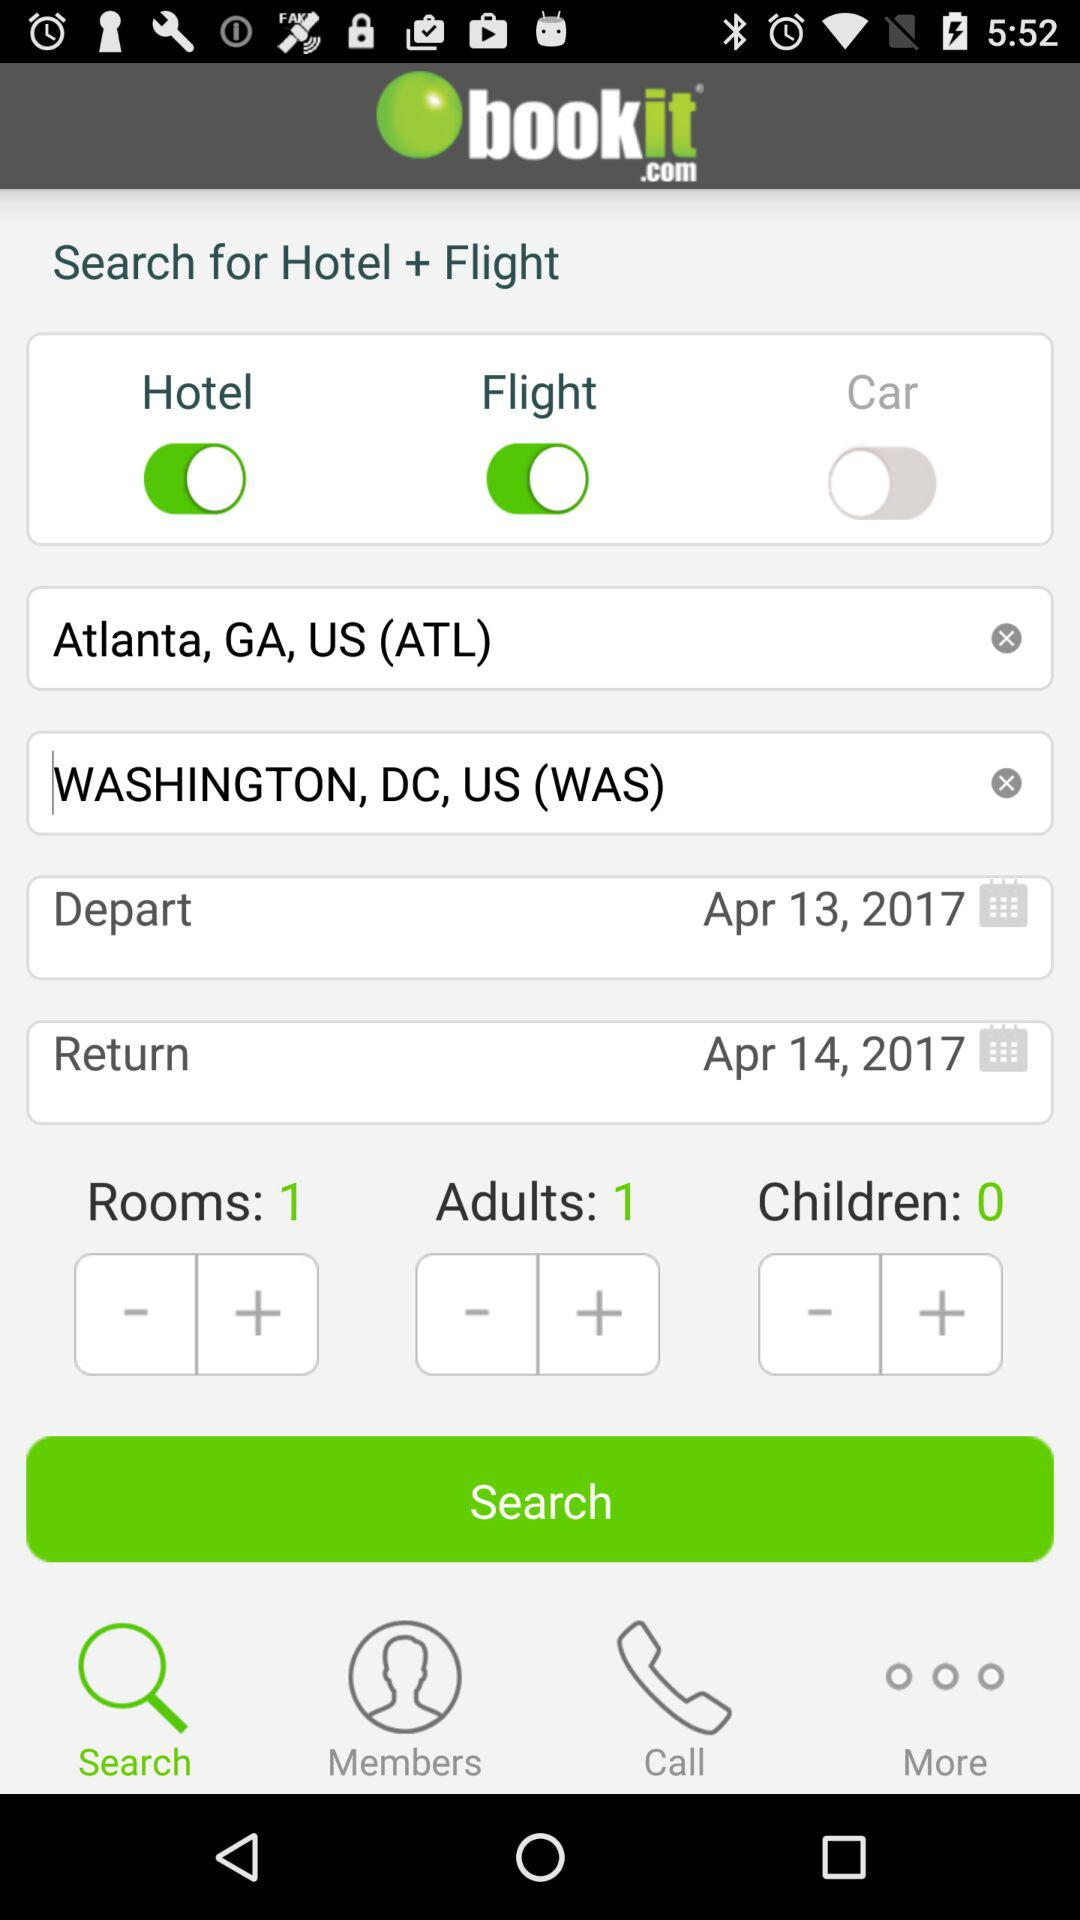How many days apart are the departure and return dates?
Answer the question using a single word or phrase. 1 